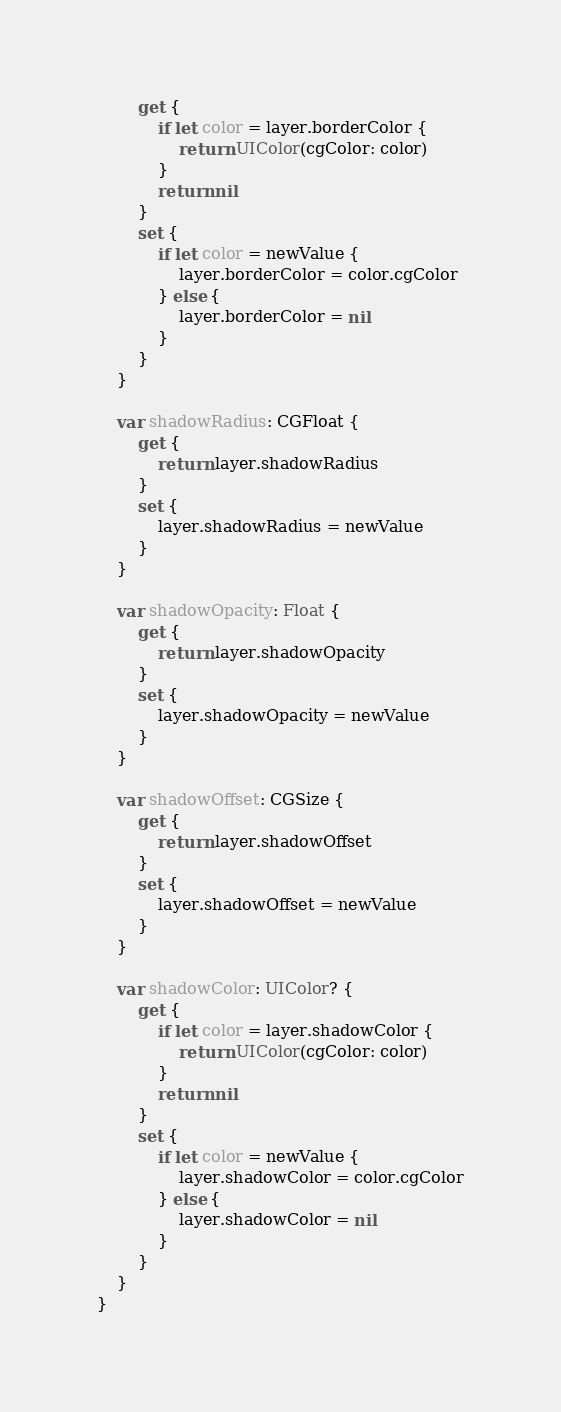Convert code to text. <code><loc_0><loc_0><loc_500><loc_500><_Swift_>        get {
            if let color = layer.borderColor {
                return UIColor(cgColor: color)
            }
            return nil
        }
        set {
            if let color = newValue {
                layer.borderColor = color.cgColor
            } else {
                layer.borderColor = nil
            }
        }
    }
    
    var shadowRadius: CGFloat {
        get {
            return layer.shadowRadius
        }
        set {
            layer.shadowRadius = newValue
        }
    }
    
    var shadowOpacity: Float {
        get {
            return layer.shadowOpacity
        }
        set {
            layer.shadowOpacity = newValue
        }
    }
    
    var shadowOffset: CGSize {
        get {
            return layer.shadowOffset
        }
        set {
            layer.shadowOffset = newValue
        }
    }
    
    var shadowColor: UIColor? {
        get {
            if let color = layer.shadowColor {
                return UIColor(cgColor: color)
            }
            return nil
        }
        set {
            if let color = newValue {
                layer.shadowColor = color.cgColor
            } else {
                layer.shadowColor = nil
            }
        }
    }
}

</code> 